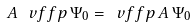Convert formula to latex. <formula><loc_0><loc_0><loc_500><loc_500>A \, \ v f f p \, \Psi _ { 0 } = \ v f f p \, A \, \Psi _ { 0 }</formula> 